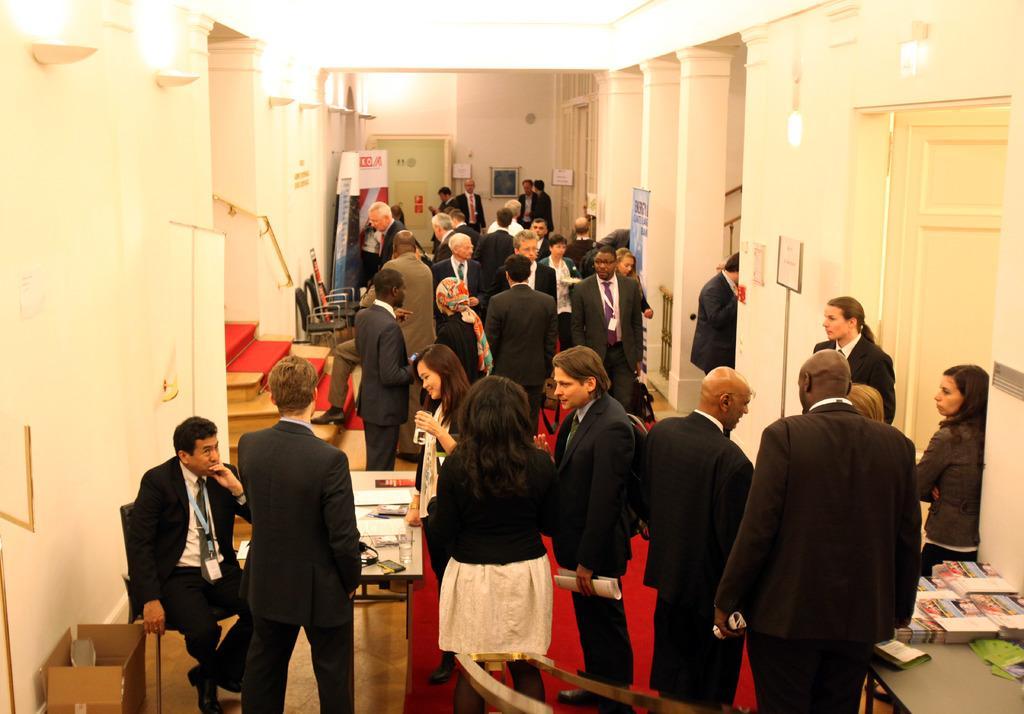Describe this image in one or two sentences. In this image there are a few people standing and few people sitting in chairs, in front of them on the tables there are some objects, there are stairs, banners, posters on the wall and pillars, there is a wooden fence, stairs, lamps on the walls, doors. 